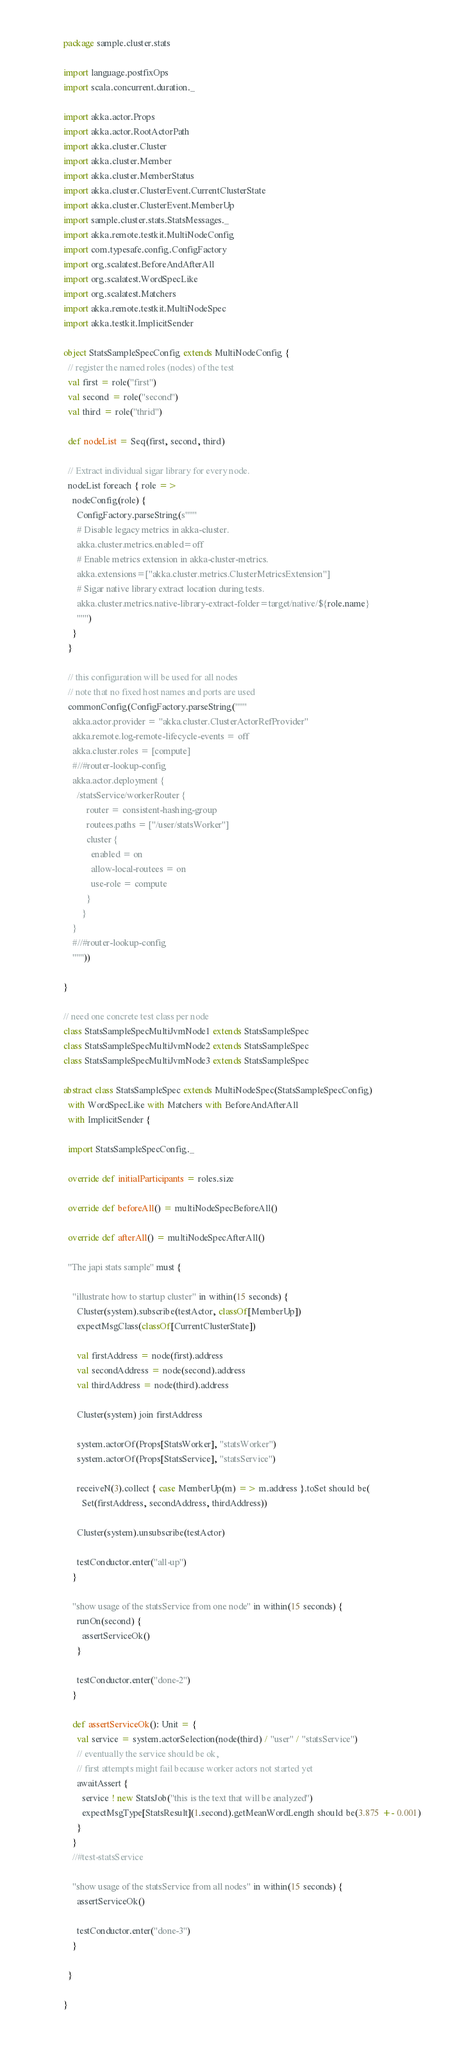Convert code to text. <code><loc_0><loc_0><loc_500><loc_500><_Scala_>package sample.cluster.stats

import language.postfixOps
import scala.concurrent.duration._

import akka.actor.Props
import akka.actor.RootActorPath
import akka.cluster.Cluster
import akka.cluster.Member
import akka.cluster.MemberStatus
import akka.cluster.ClusterEvent.CurrentClusterState
import akka.cluster.ClusterEvent.MemberUp
import sample.cluster.stats.StatsMessages._
import akka.remote.testkit.MultiNodeConfig
import com.typesafe.config.ConfigFactory
import org.scalatest.BeforeAndAfterAll
import org.scalatest.WordSpecLike
import org.scalatest.Matchers
import akka.remote.testkit.MultiNodeSpec
import akka.testkit.ImplicitSender

object StatsSampleSpecConfig extends MultiNodeConfig {
  // register the named roles (nodes) of the test
  val first = role("first")
  val second = role("second")
  val third = role("thrid")

  def nodeList = Seq(first, second, third)

  // Extract individual sigar library for every node.
  nodeList foreach { role =>
    nodeConfig(role) {
      ConfigFactory.parseString(s"""
      # Disable legacy metrics in akka-cluster.
      akka.cluster.metrics.enabled=off
      # Enable metrics extension in akka-cluster-metrics.
      akka.extensions=["akka.cluster.metrics.ClusterMetricsExtension"]
      # Sigar native library extract location during tests.
      akka.cluster.metrics.native-library-extract-folder=target/native/${role.name}
      """)
    }
  }

  // this configuration will be used for all nodes
  // note that no fixed host names and ports are used
  commonConfig(ConfigFactory.parseString("""
    akka.actor.provider = "akka.cluster.ClusterActorRefProvider"
    akka.remote.log-remote-lifecycle-events = off
    akka.cluster.roles = [compute]
    #//#router-lookup-config  
    akka.actor.deployment {
      /statsService/workerRouter {
          router = consistent-hashing-group
          routees.paths = ["/user/statsWorker"]
          cluster {
            enabled = on
            allow-local-routees = on
            use-role = compute
          }
        }
    }
    #//#router-lookup-config  
    """))

}

// need one concrete test class per node
class StatsSampleSpecMultiJvmNode1 extends StatsSampleSpec
class StatsSampleSpecMultiJvmNode2 extends StatsSampleSpec
class StatsSampleSpecMultiJvmNode3 extends StatsSampleSpec

abstract class StatsSampleSpec extends MultiNodeSpec(StatsSampleSpecConfig)
  with WordSpecLike with Matchers with BeforeAndAfterAll
  with ImplicitSender {

  import StatsSampleSpecConfig._

  override def initialParticipants = roles.size

  override def beforeAll() = multiNodeSpecBeforeAll()

  override def afterAll() = multiNodeSpecAfterAll()

  "The japi stats sample" must {

    "illustrate how to startup cluster" in within(15 seconds) {
      Cluster(system).subscribe(testActor, classOf[MemberUp])
      expectMsgClass(classOf[CurrentClusterState])

      val firstAddress = node(first).address
      val secondAddress = node(second).address
      val thirdAddress = node(third).address

      Cluster(system) join firstAddress

      system.actorOf(Props[StatsWorker], "statsWorker")
      system.actorOf(Props[StatsService], "statsService")

      receiveN(3).collect { case MemberUp(m) => m.address }.toSet should be(
        Set(firstAddress, secondAddress, thirdAddress))

      Cluster(system).unsubscribe(testActor)

      testConductor.enter("all-up")
    }

    "show usage of the statsService from one node" in within(15 seconds) {
      runOn(second) {
        assertServiceOk()
      }

      testConductor.enter("done-2")
    }

    def assertServiceOk(): Unit = {
      val service = system.actorSelection(node(third) / "user" / "statsService")
      // eventually the service should be ok,
      // first attempts might fail because worker actors not started yet
      awaitAssert {
        service ! new StatsJob("this is the text that will be analyzed")
        expectMsgType[StatsResult](1.second).getMeanWordLength should be(3.875 +- 0.001)
      }
    }
    //#test-statsService

    "show usage of the statsService from all nodes" in within(15 seconds) {
      assertServiceOk()

      testConductor.enter("done-3")
    }

  }

}
</code> 